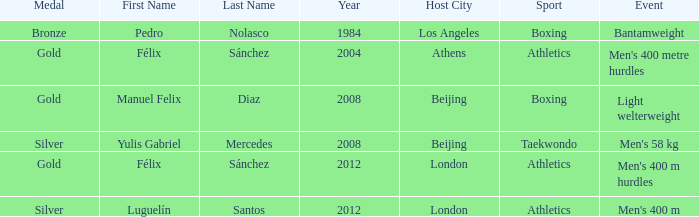Which medal was associated with félix sánchez and the 2012 london games? Gold. 